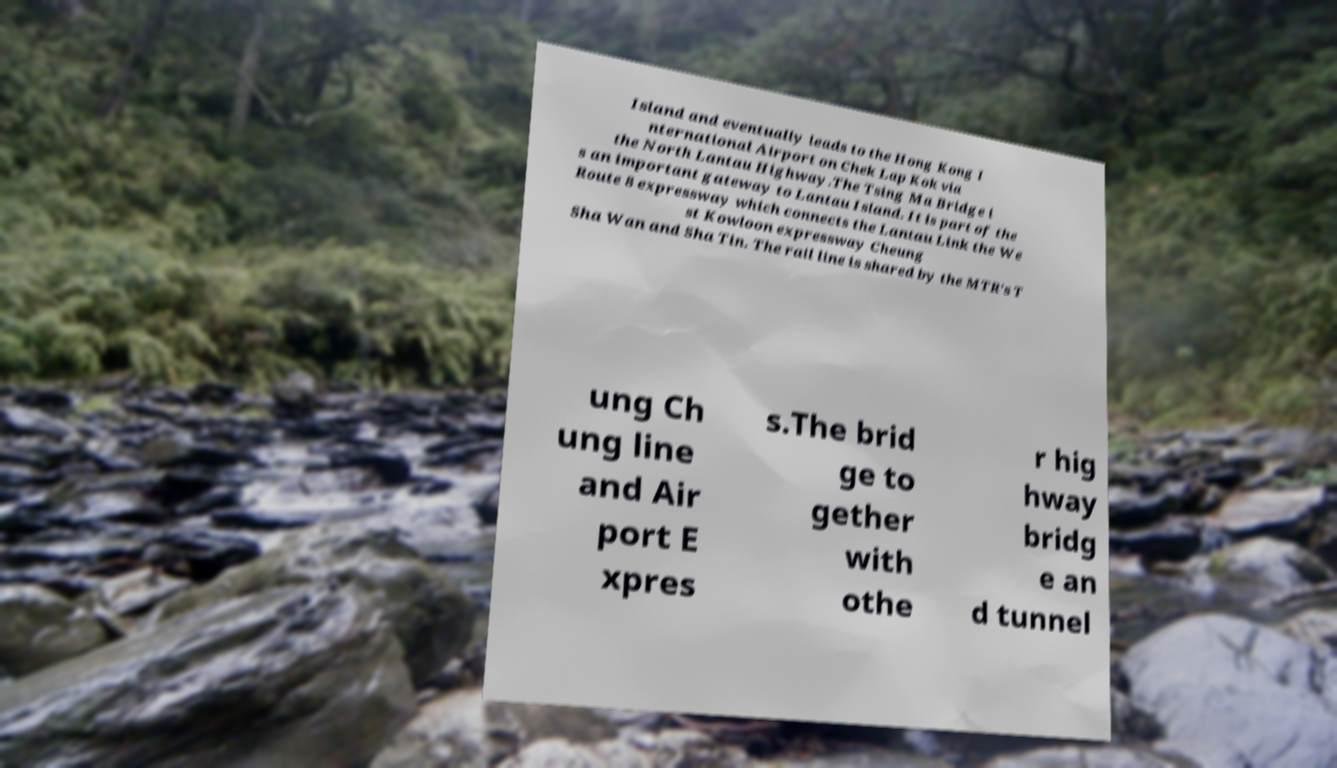Can you read and provide the text displayed in the image?This photo seems to have some interesting text. Can you extract and type it out for me? Island and eventually leads to the Hong Kong I nternational Airport on Chek Lap Kok via the North Lantau Highway.The Tsing Ma Bridge i s an important gateway to Lantau Island. It is part of the Route 8 expressway which connects the Lantau Link the We st Kowloon expressway Cheung Sha Wan and Sha Tin. The rail line is shared by the MTR's T ung Ch ung line and Air port E xpres s.The brid ge to gether with othe r hig hway bridg e an d tunnel 